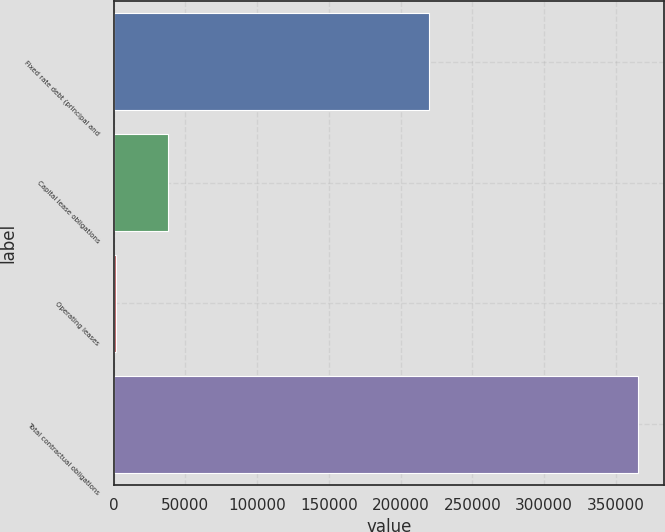<chart> <loc_0><loc_0><loc_500><loc_500><bar_chart><fcel>Fixed rate debt (principal and<fcel>Capital lease obligations<fcel>Operating leases<fcel>Total contractual obligations<nl><fcel>219961<fcel>37885.8<fcel>1467<fcel>365655<nl></chart> 